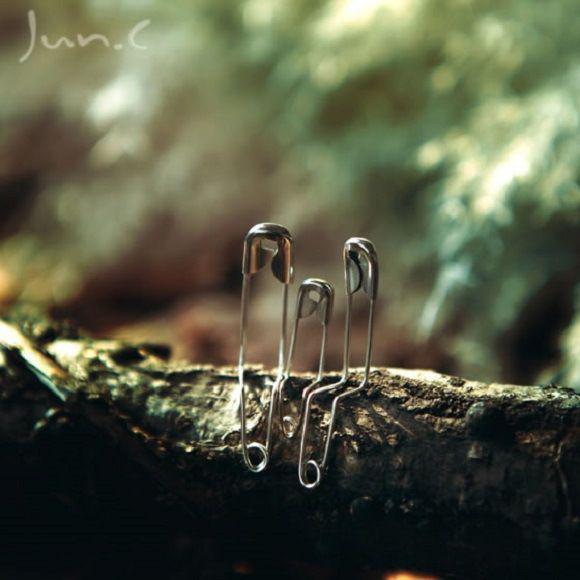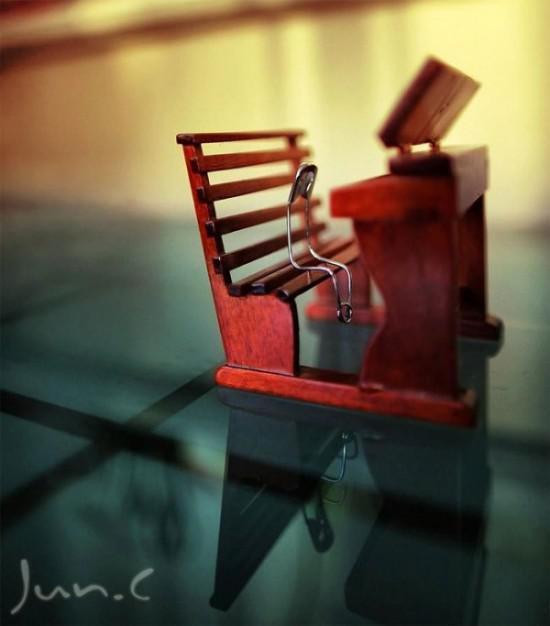The first image is the image on the left, the second image is the image on the right. Analyze the images presented: Is the assertion "a bobby pin is bent and sitting on a tiny chair" valid? Answer yes or no. Yes. The first image is the image on the left, the second image is the image on the right. Given the left and right images, does the statement "One safety pin is open and bent with it' sharp point above another safety pin." hold true? Answer yes or no. No. 